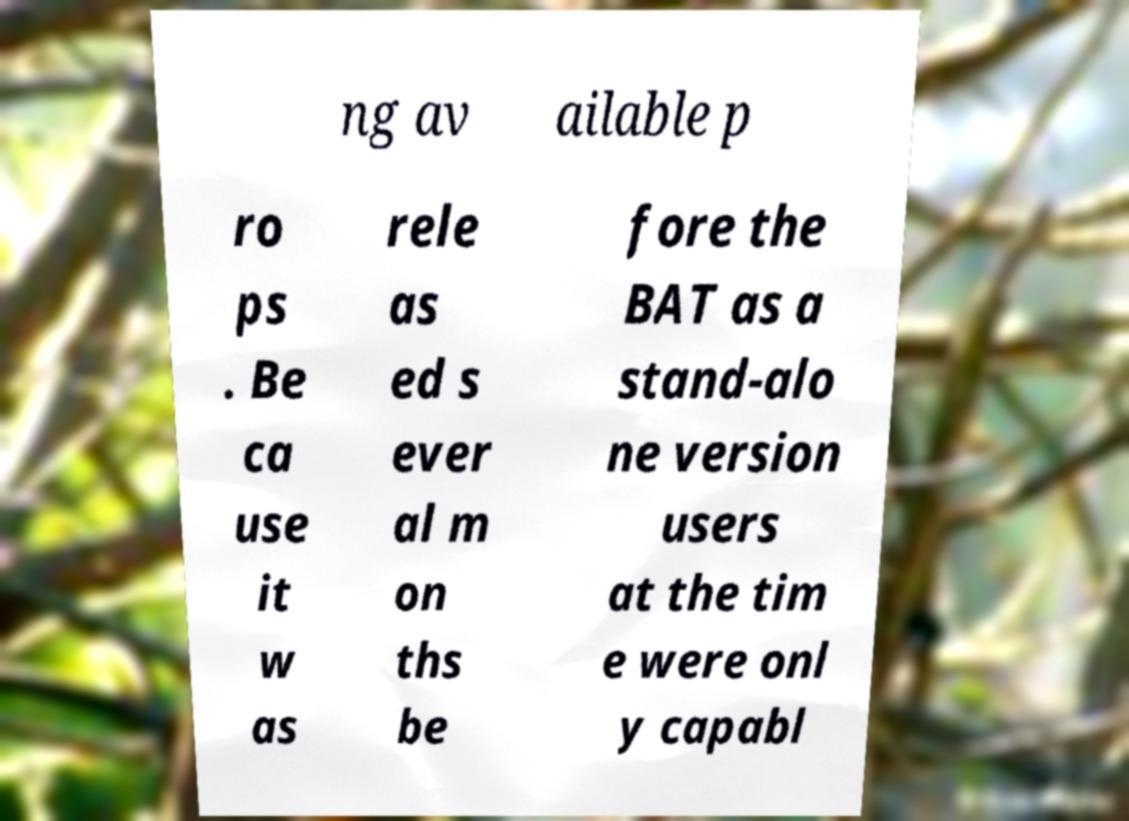Please read and relay the text visible in this image. What does it say? ng av ailable p ro ps . Be ca use it w as rele as ed s ever al m on ths be fore the BAT as a stand-alo ne version users at the tim e were onl y capabl 